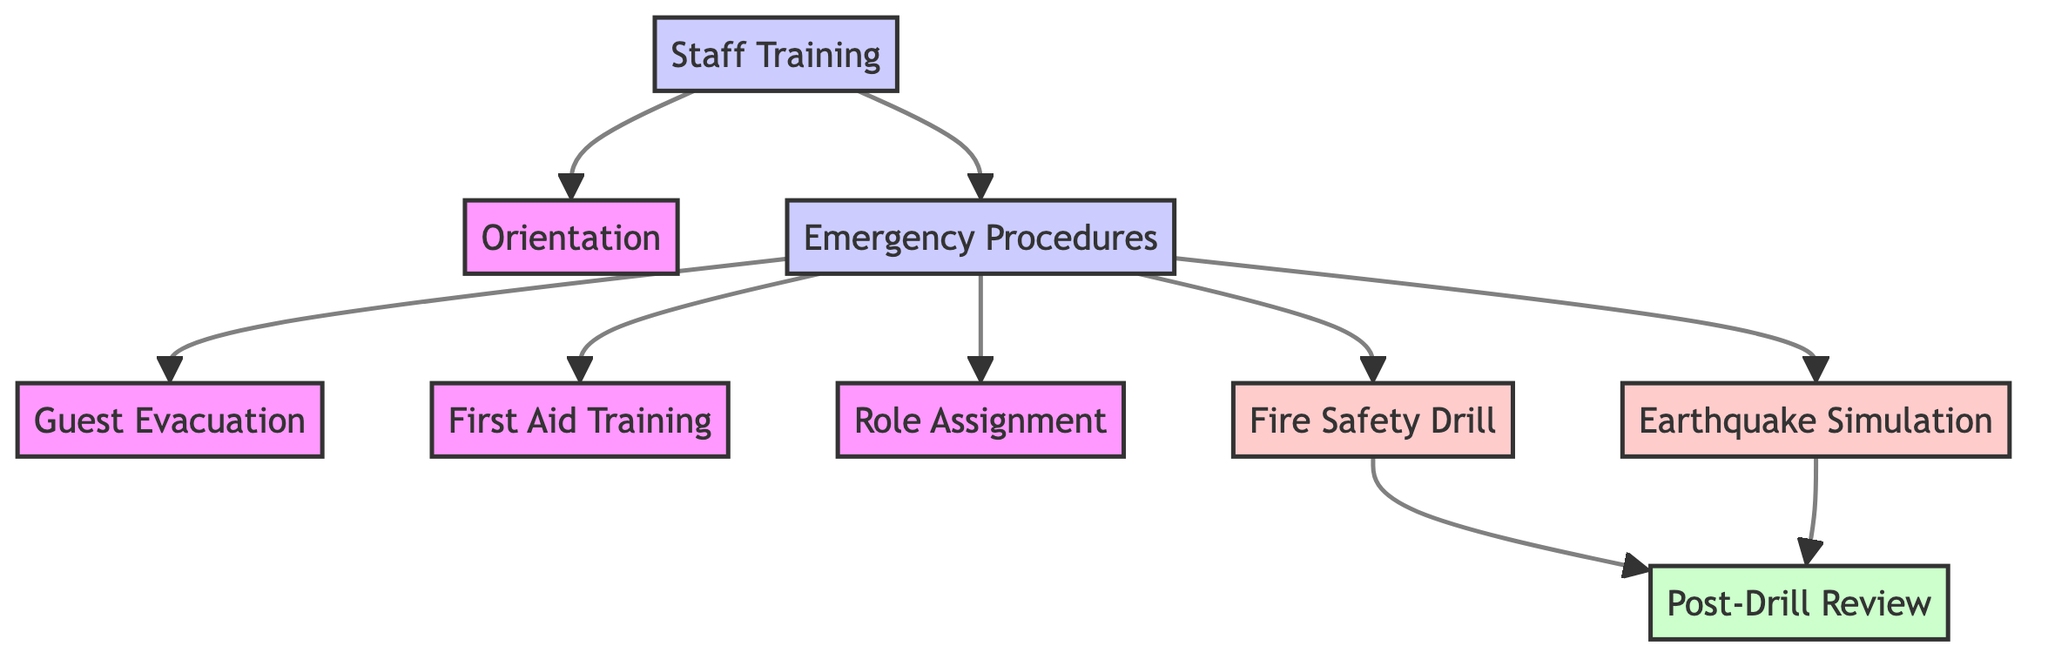What is the total number of nodes in the diagram? The nodes in the diagram are: Staff Training, Orientation, Emergency Procedures, Guest Evacuation, First Aid Training, Role Assignment, Fire Safety Drill, Earthquake Simulation, and Post-Drill Review. Counting these gives a total of 9 nodes.
Answer: 9 How many edges are connecting the nodes in the diagram? The edges connecting the nodes are as follows: Staff Training to Orientation, Staff Training to Emergency Procedures, Emergency Procedures to Guest Evacuation, Emergency Procedures to First Aid Training, Emergency Procedures to Role Assignment, Emergency Procedures to Fire Safety Drill, Emergency Procedures to Earthquake Simulation, Fire Safety Drill to Post-Drill Review, and Earthquake Simulation to Post-Drill Review. There are a total of 8 edges in the diagram.
Answer: 8 What follows "Emergency Procedures" directly in the diagram? The edges from Emergency Procedures lead to Guest Evacuation, First Aid Training, Role Assignment, Fire Safety Drill, and Earthquake Simulation. Therefore, there are several nodes that follow Emergency Procedures, specifically Guest Evacuation, First Aid Training, Role Assignment, Fire Safety Drill, and Earthquake Simulation.
Answer: Guest Evacuation, First Aid Training, Role Assignment, Fire Safety Drill, Earthquake Simulation Which node is a drill in the diagram? According to the classification in the diagram, the nodes Fire Safety Drill and Earthquake Simulation are both marked as drills. Therefore, the answer would be Fire Safety Drill and Earthquake Simulation.
Answer: Fire Safety Drill, Earthquake Simulation What is the direct result of the "Fire Safety Drill"? The Fire Safety Drill has a direct edge leading to Post-Drill Review, indicating that after conducting a fire safety drill, the next step is to carry out a review.
Answer: Post-Drill Review Which node is the starting point for the training program? The starting point in the diagram is Staff Training, as it is the primary node from which all other activities flow.
Answer: Staff Training 